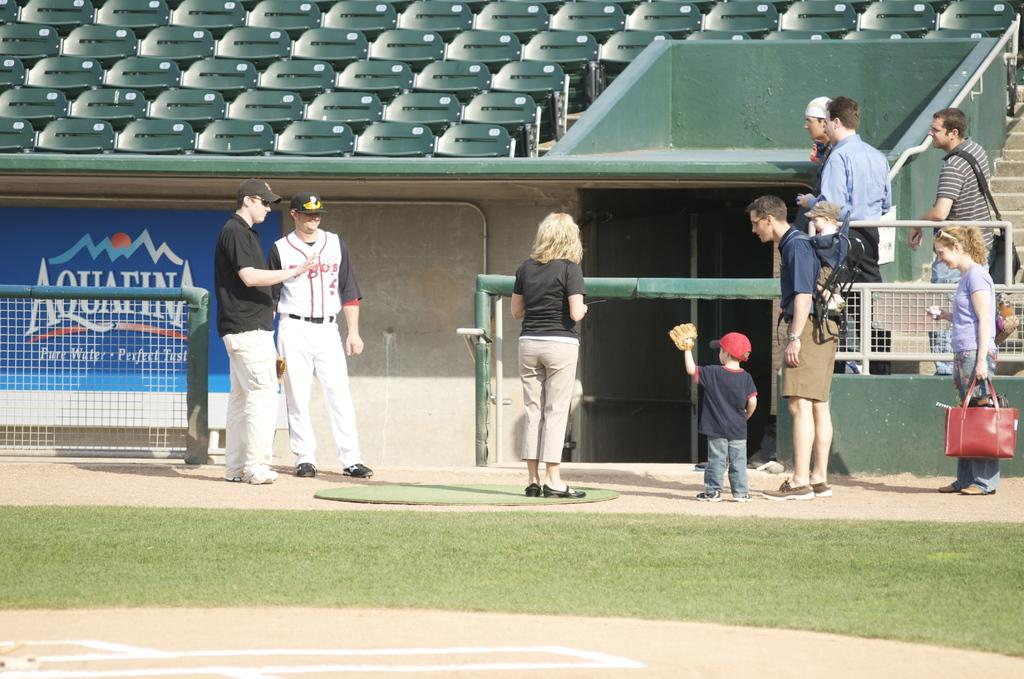<image>
Offer a succinct explanation of the picture presented. some people doing an interview at a baseball stadiumwith an Aquafina sign on the wall 